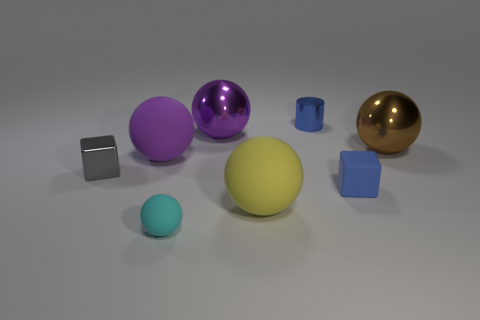There is a small blue thing that is in front of the gray object; how many big purple balls are in front of it?
Ensure brevity in your answer.  0. What is the shape of the small rubber object that is in front of the matte cube?
Your answer should be compact. Sphere. There is a small blue thing in front of the purple object left of the cyan object that is in front of the yellow rubber sphere; what is its material?
Make the answer very short. Rubber. What material is the big yellow thing that is the same shape as the large brown metal thing?
Your answer should be very brief. Rubber. What color is the small shiny block?
Give a very brief answer. Gray. What color is the metal ball that is on the right side of the large sphere that is in front of the blue rubber cube?
Your answer should be very brief. Brown. There is a small shiny cylinder; does it have the same color as the tiny rubber object to the left of the blue cube?
Give a very brief answer. No. There is a purple sphere that is right of the big matte ball that is behind the gray cube; what number of large spheres are behind it?
Ensure brevity in your answer.  0. There is a metallic block; are there any cubes to the right of it?
Your answer should be very brief. Yes. Is there anything else that has the same color as the tiny metallic cylinder?
Keep it short and to the point. Yes. 